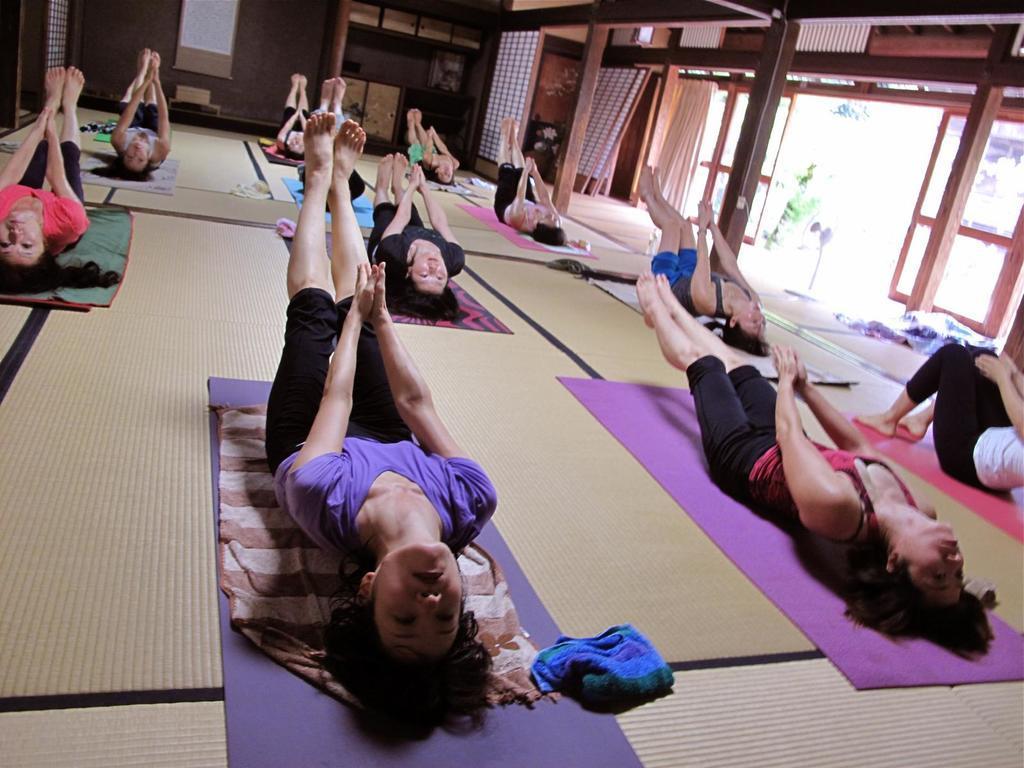Describe this image in one or two sentences. In this image we can see women doing exercise on the floor. In the background there is a wall, curtains, doors and windows. 